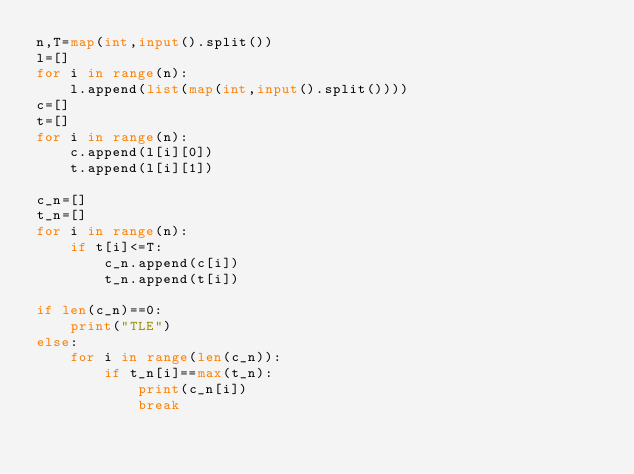Convert code to text. <code><loc_0><loc_0><loc_500><loc_500><_Python_>n,T=map(int,input().split())
l=[]
for i in range(n):
    l.append(list(map(int,input().split())))
c=[]
t=[]
for i in range(n):
    c.append(l[i][0])
    t.append(l[i][1])

c_n=[]
t_n=[]
for i in range(n):
    if t[i]<=T:
        c_n.append(c[i])
        t_n.append(t[i])

if len(c_n)==0:
    print("TLE")
else:
    for i in range(len(c_n)):
        if t_n[i]==max(t_n):
            print(c_n[i])
            break


</code> 